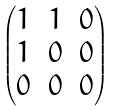Convert formula to latex. <formula><loc_0><loc_0><loc_500><loc_500>\begin{pmatrix} 1 & 1 & 0 \\ 1 & 0 & 0 \\ 0 & 0 & 0 \end{pmatrix}</formula> 